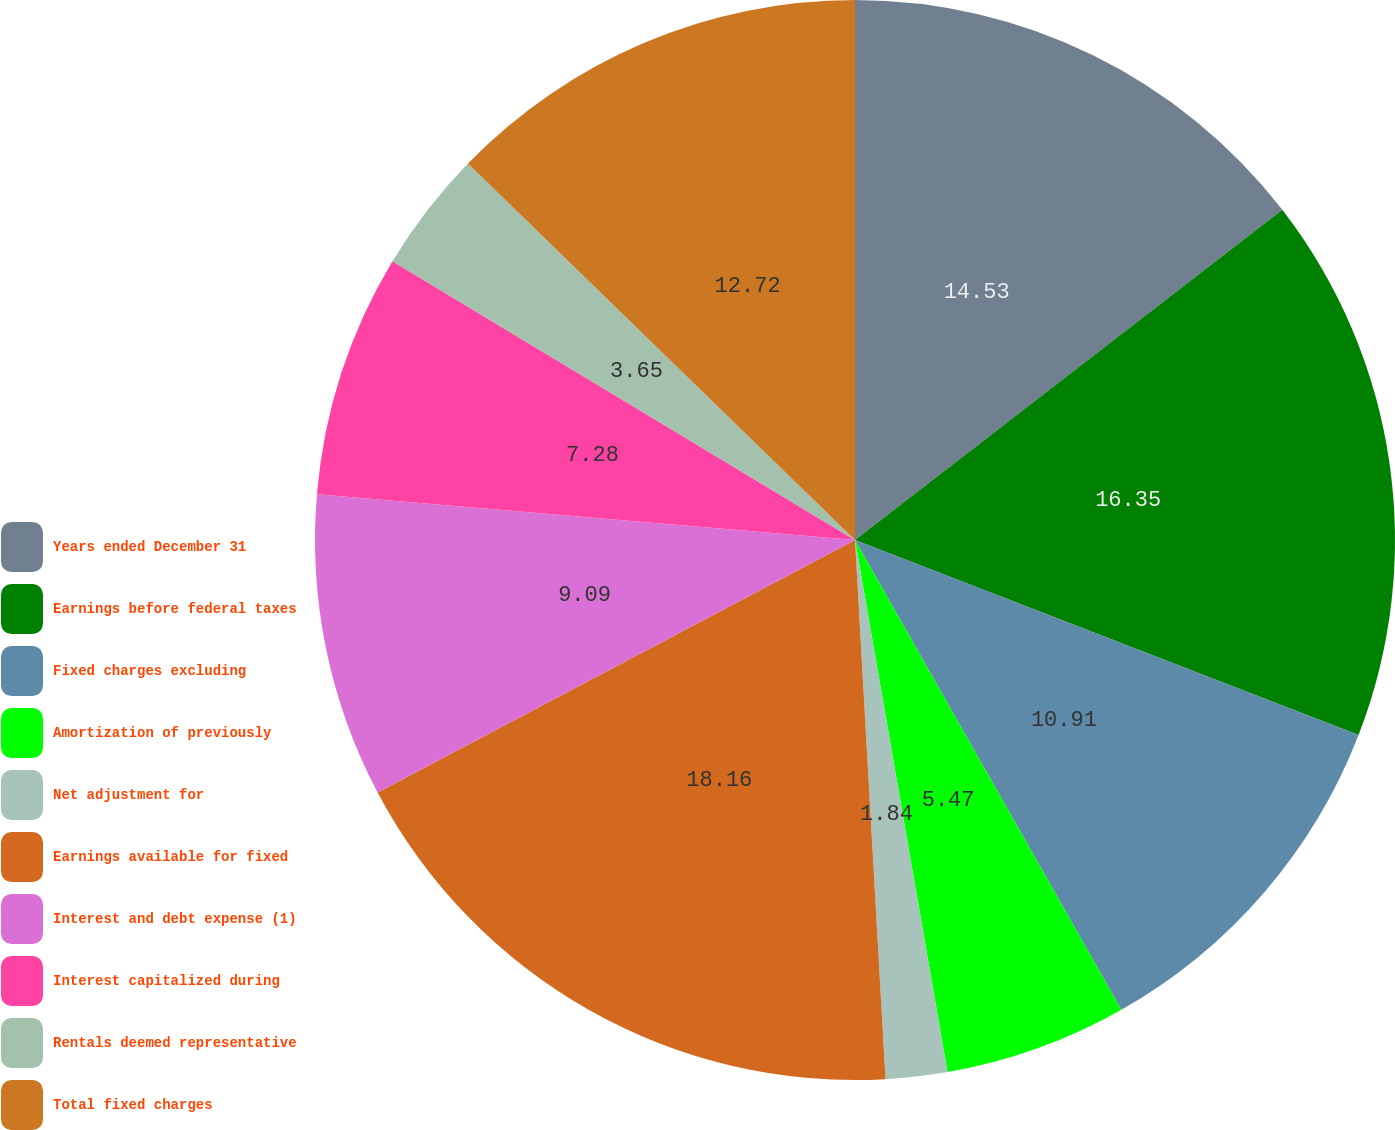Convert chart to OTSL. <chart><loc_0><loc_0><loc_500><loc_500><pie_chart><fcel>Years ended December 31<fcel>Earnings before federal taxes<fcel>Fixed charges excluding<fcel>Amortization of previously<fcel>Net adjustment for<fcel>Earnings available for fixed<fcel>Interest and debt expense (1)<fcel>Interest capitalized during<fcel>Rentals deemed representative<fcel>Total fixed charges<nl><fcel>14.53%<fcel>16.35%<fcel>10.91%<fcel>5.47%<fcel>1.84%<fcel>18.16%<fcel>9.09%<fcel>7.28%<fcel>3.65%<fcel>12.72%<nl></chart> 